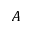<formula> <loc_0><loc_0><loc_500><loc_500>A</formula> 